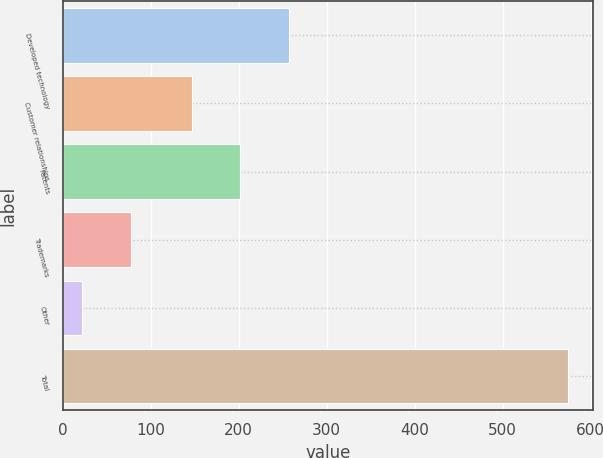Convert chart. <chart><loc_0><loc_0><loc_500><loc_500><bar_chart><fcel>Developed technology<fcel>Customer relationships<fcel>Patents<fcel>Trademarks<fcel>Other<fcel>Total<nl><fcel>257.04<fcel>146.6<fcel>201.82<fcel>77.42<fcel>22.2<fcel>574.4<nl></chart> 